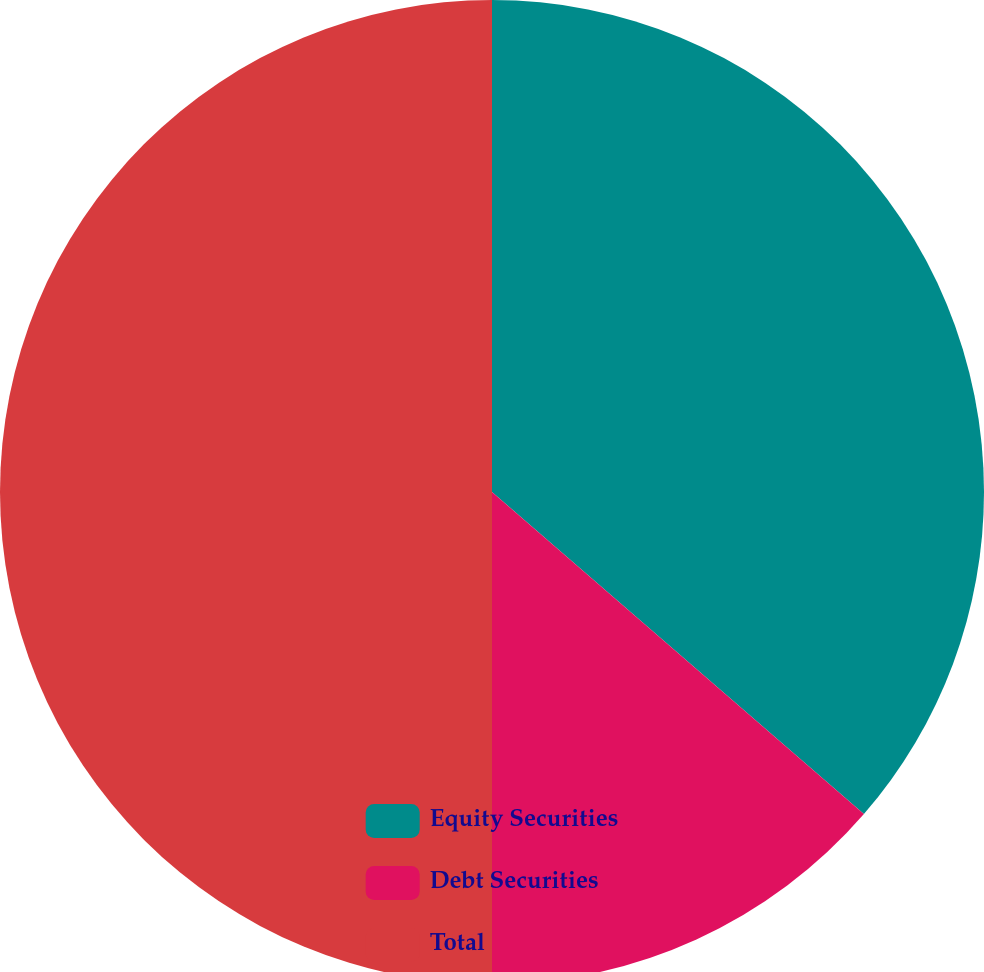<chart> <loc_0><loc_0><loc_500><loc_500><pie_chart><fcel>Equity Securities<fcel>Debt Securities<fcel>Total<nl><fcel>36.36%<fcel>13.64%<fcel>50.0%<nl></chart> 